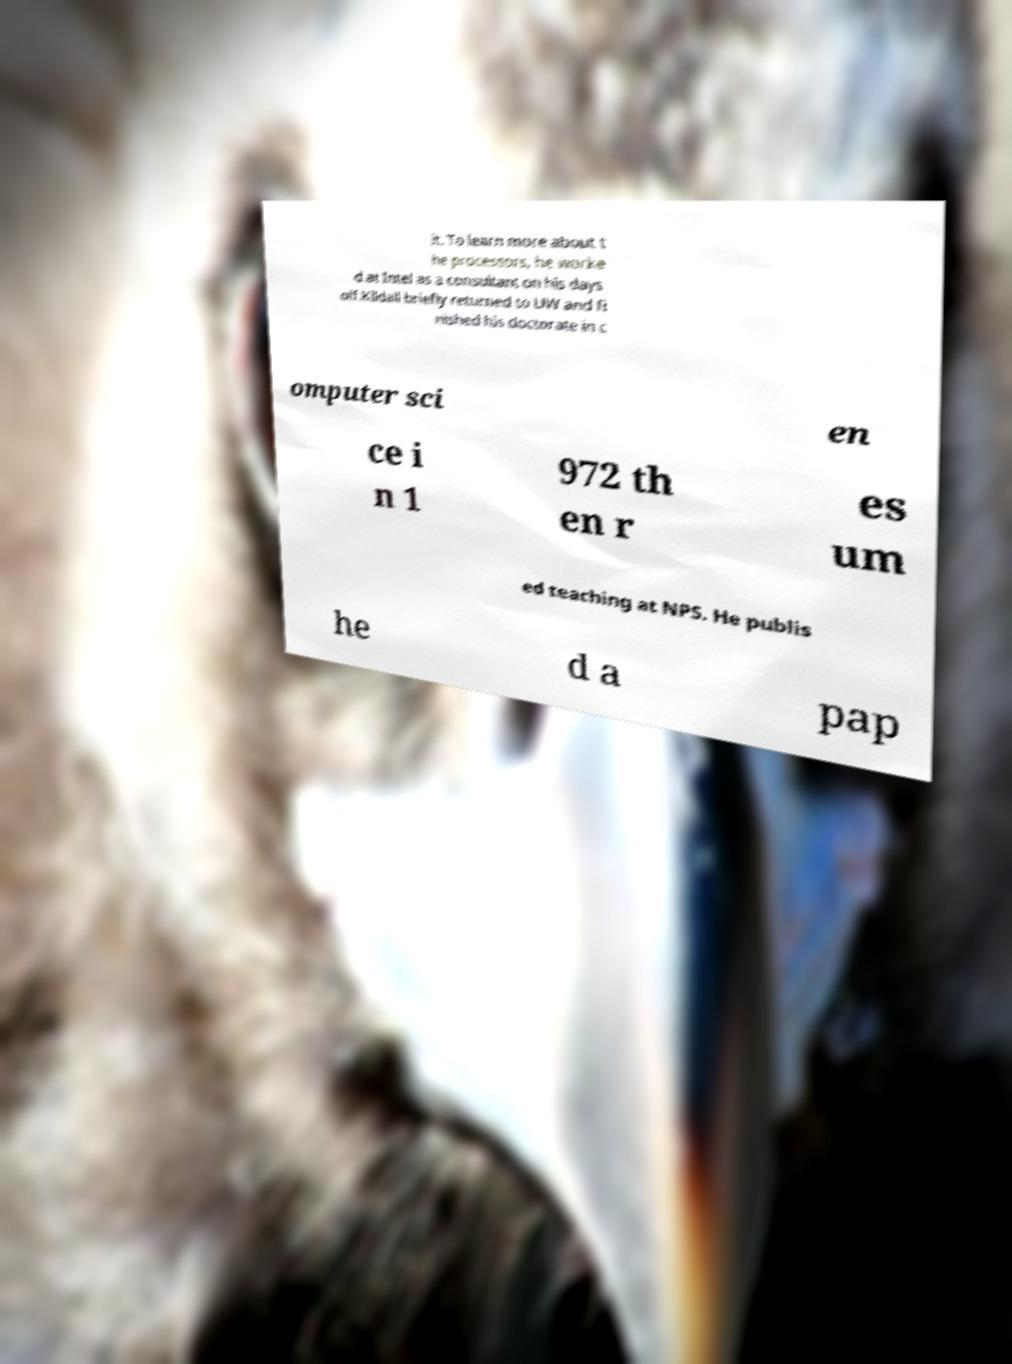Please identify and transcribe the text found in this image. it. To learn more about t he processors, he worke d at Intel as a consultant on his days off.Kildall briefly returned to UW and fi nished his doctorate in c omputer sci en ce i n 1 972 th en r es um ed teaching at NPS. He publis he d a pap 